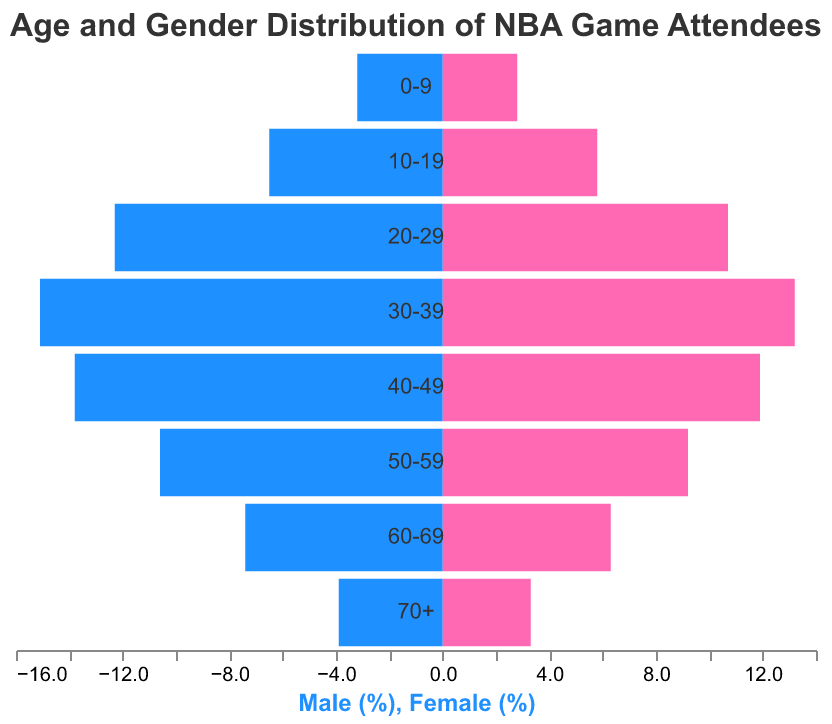What is the title of the population pyramid? The title is displayed at the top of the figure and reads "Age and Gender Distribution of NBA Game Attendees."
Answer: Age and Gender Distribution of NBA Game Attendees Which age group has the highest percentage of male attendees? By comparing the negative bars (blue) associated with each age group, the 30-39 age group has the longest bar to the left, representing the highest percentage of male attendees.
Answer: 30-39 What is the percentage of female attendees in the 50-59 age group? The length of the pink bar corresponding to the 50-59 age group shows the percentage of female attendees, which is marked on the x-axis as 9.2%.
Answer: 9.2% How many age groups are displayed in the population pyramid? By counting the distinct age groups labeled on the y-axis, we can determine there are eight age groups.
Answer: 8 What is the percentage difference between male and female attendees in the 30-39 age group? The percentage for male attendees is 15.1% and for female attendees is 13.2%, the difference is calculated by subtracting the female percentage from the male percentage: 15.1% - 13.2% = 1.9%.
Answer: 1.9% In which age group is the percentage of male attendees closest to the percentage of female attendees? By looking at the bars' lengths for each age group, the age group 0-9 shows a small difference between male (3.2%) and female (2.8%) attendees, so we calculate the difference: 3.2% - 2.8% = 0.4%. This is the smallest difference.
Answer: 0-9 Are there more female attendees in the 20-29 age group than male attendees in the 0-9 age group? The length of the pink bar for the 20-29 age group indicates 10.7% of female attendees, while the length of the blue bar for the 0-9 age group indicates 3.2% of male attendees. Comparing these two values shows that 10.7% is greater than 3.2%.
Answer: Yes In the 70+ age group, how does the percentage of male attendees compare to the percentage of female attendees? By comparing the lengths of the bars for the 70+ age group, the male percentage is 3.9%, and the female percentage is 3.3%. The male percentage is slightly higher.
Answer: Male percentage is higher Which age group has the second-highest percentage of female attendees? By inspecting the lengths of the pink bars across all age groups, the longest bar is for the 30-39 age group (13.2%), and the second longest is for the 20-29 age group (10.7%). Therefore, the second-highest percentage of female attendees is in the 20-29 age group.
Answer: 20-29 